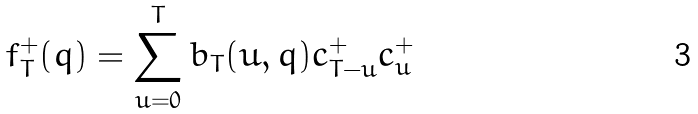<formula> <loc_0><loc_0><loc_500><loc_500>f ^ { + } _ { T } ( q ) = \sum _ { u = 0 } ^ { T } b _ { T } ( u , q ) c ^ { + } _ { T - u } c ^ { + } _ { u }</formula> 